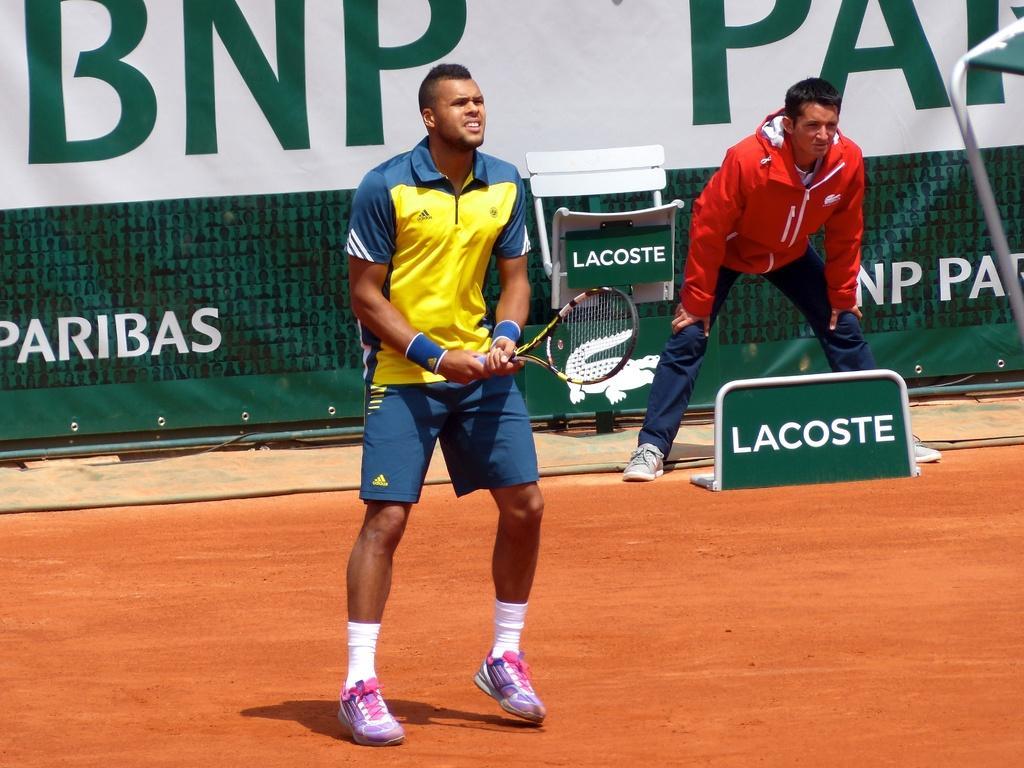Describe this image in one or two sentences. The person is standing and holding a tennis racket in his hand and there is another person standing behind him and there is a banner in the background which has something written on it. 